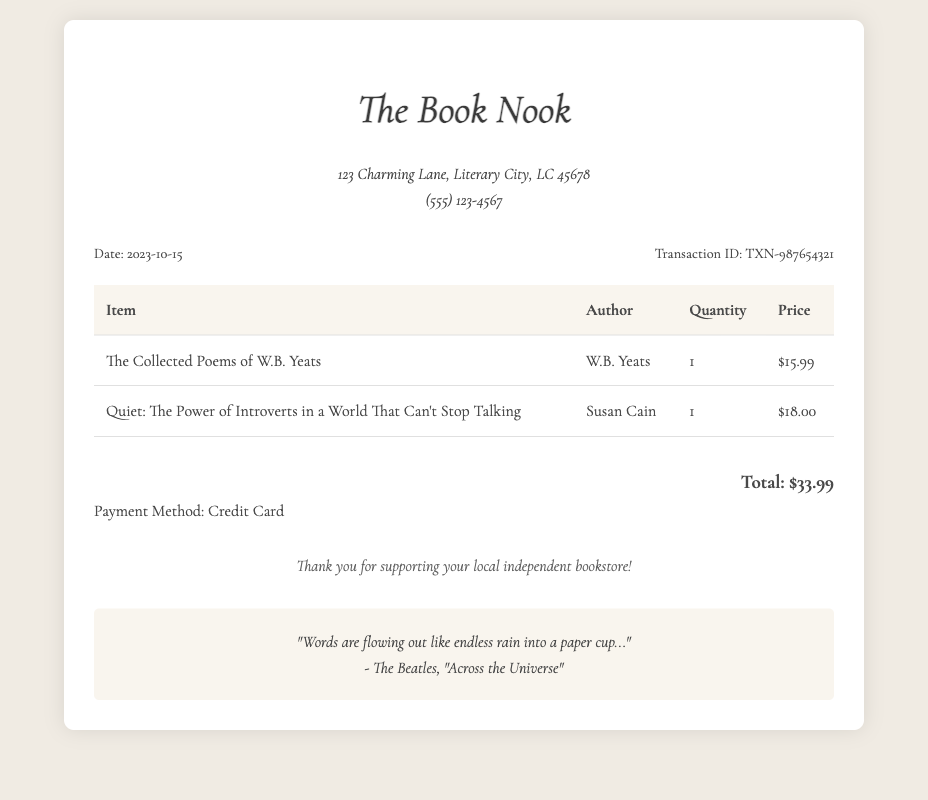What is the date of the transaction? The date of the transaction is clearly stated in the document under the transaction details as October 15, 2023.
Answer: 2023-10-15 What is the total amount paid? The total amount paid is summarized at the bottom of the receipt, which sums the prices of the books purchased.
Answer: $33.99 Who is the author of "Quiet: The Power of Introverts in a World That Can't Stop Talking"? The author of "Quiet" is explicitly mentioned in the table of items listed in the receipt.
Answer: Susan Cain How many items were purchased? The number of items can be inferred from the quantity listed in the table and the total number of titles.
Answer: 2 What is the payment method used? The payment method is specified clearly below the total amount section in the receipt.
Answer: Credit Card What is the title of the first book listed? The title of the first book is found in the first row of the table of items presented on the receipt.
Answer: The Collected Poems of W.B. Yeats Which bookstore issued this receipt? The name of the bookstore is prominently displayed at the top of the document.
Answer: The Book Nook What is the phone number of the bookstore? The phone number of the bookstore is provided in the store information section of the receipt.
Answer: (555) 123-4567 